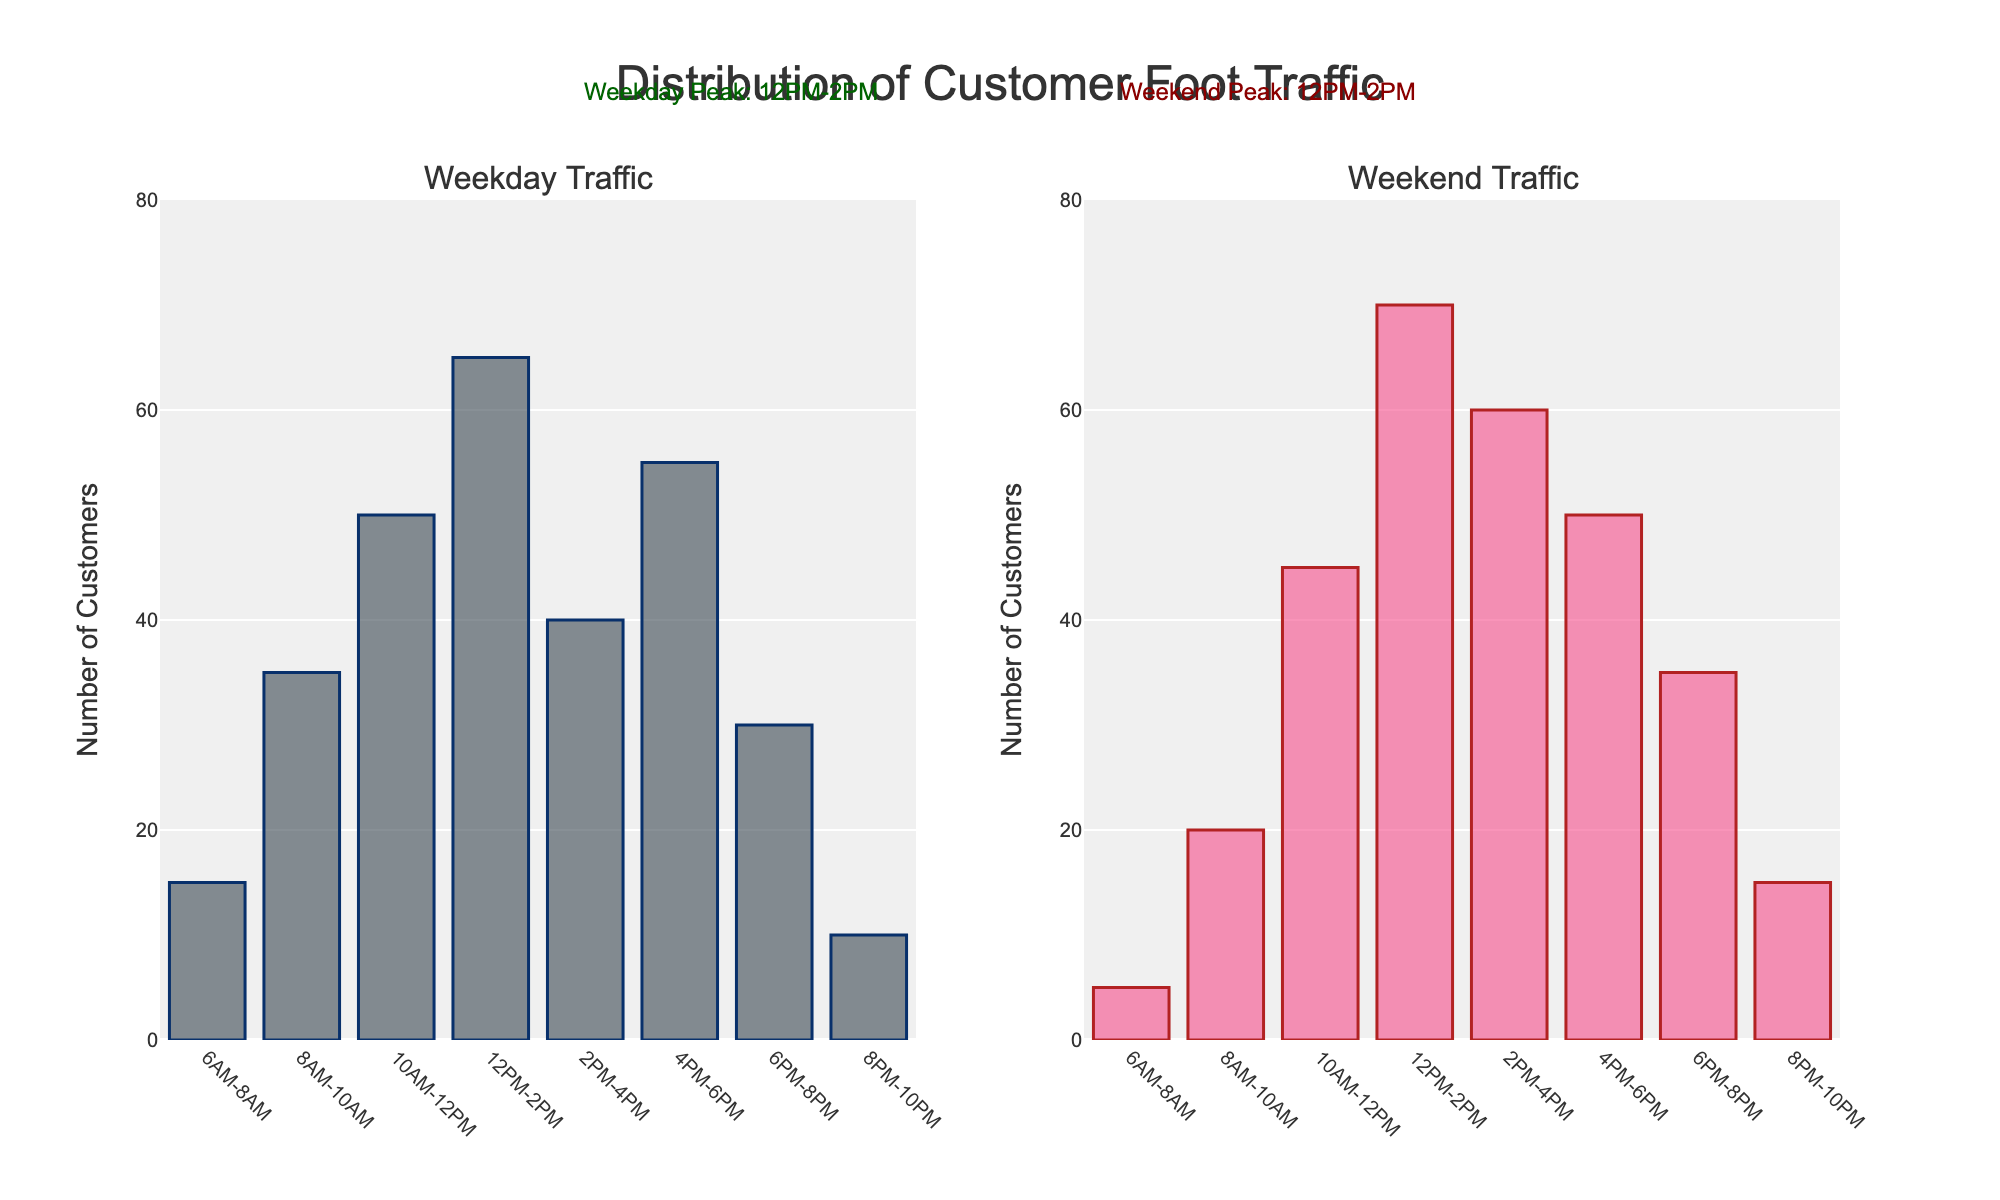How many customers visited the cart during the 12PM-2PM period on weekdays? The weekday traffic bar at 12PM-2PM represents the highest value, which can be seen to be 65 customers.
Answer: 65 What is the difference in customer traffic between weekdays and weekends during the 8AM-10AM period? The weekday traffic for 8AM-10AM is 35, while the weekend traffic is 20. The difference is 35 - 20 = 15.
Answer: 15 During which time period is the peak customer traffic for weekends? The annotation in the weekend subplot indicates the peak customer traffic is at 12PM-2PM, which matches the highest bar in the weekend traffic at 70 customers.
Answer: 12PM-2PM What is the total customer traffic for weekdays from 6AM to 10AM? Summing the weekday traffic from 6AM-8AM and 8AM-10AM yields 15 (for 6AM-8AM) + 35 (for 8AM-10AM) = 50 customers.
Answer: 50 Which period shows a higher traffic on weekdays compared to weekends: 6PM-8PM or 4PM-6PM? For 6PM-8PM, weekdays have 30 and weekends have 35, which means weekends are higher. For 4PM-6PM, weekdays have 55 and weekends have 50, so weekdays are higher there. Thus, 4PM-6PM is the period where weekdays have higher traffic compared to weekends.
Answer: 4PM-6PM How does the customer traffic change from the 2PM-4PM to 4PM-6PM period on weekdays? Weekday traffic from 2PM-4PM is 40 and from 4PM-6PM is 55, indicating an increase by 15 customers.
Answer: An increase by 15 customers What is the average customer traffic during the 10AM-12PM period for both weekdays and weekends? The traffic is 50 for weekdays and 45 for weekends. The average is (50 + 45) / 2 = 47.5.
Answer: 47.5 Compare the foot traffic during the first and last periods of the day on weekends. The weekend traffic for 6AM-8AM is 5, and for 8PM-10PM is 15. Clearly, the last period has more traffic than the first period by 10 customers.
Answer: Last period has 10 more customers 